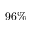<formula> <loc_0><loc_0><loc_500><loc_500>9 6 \%</formula> 